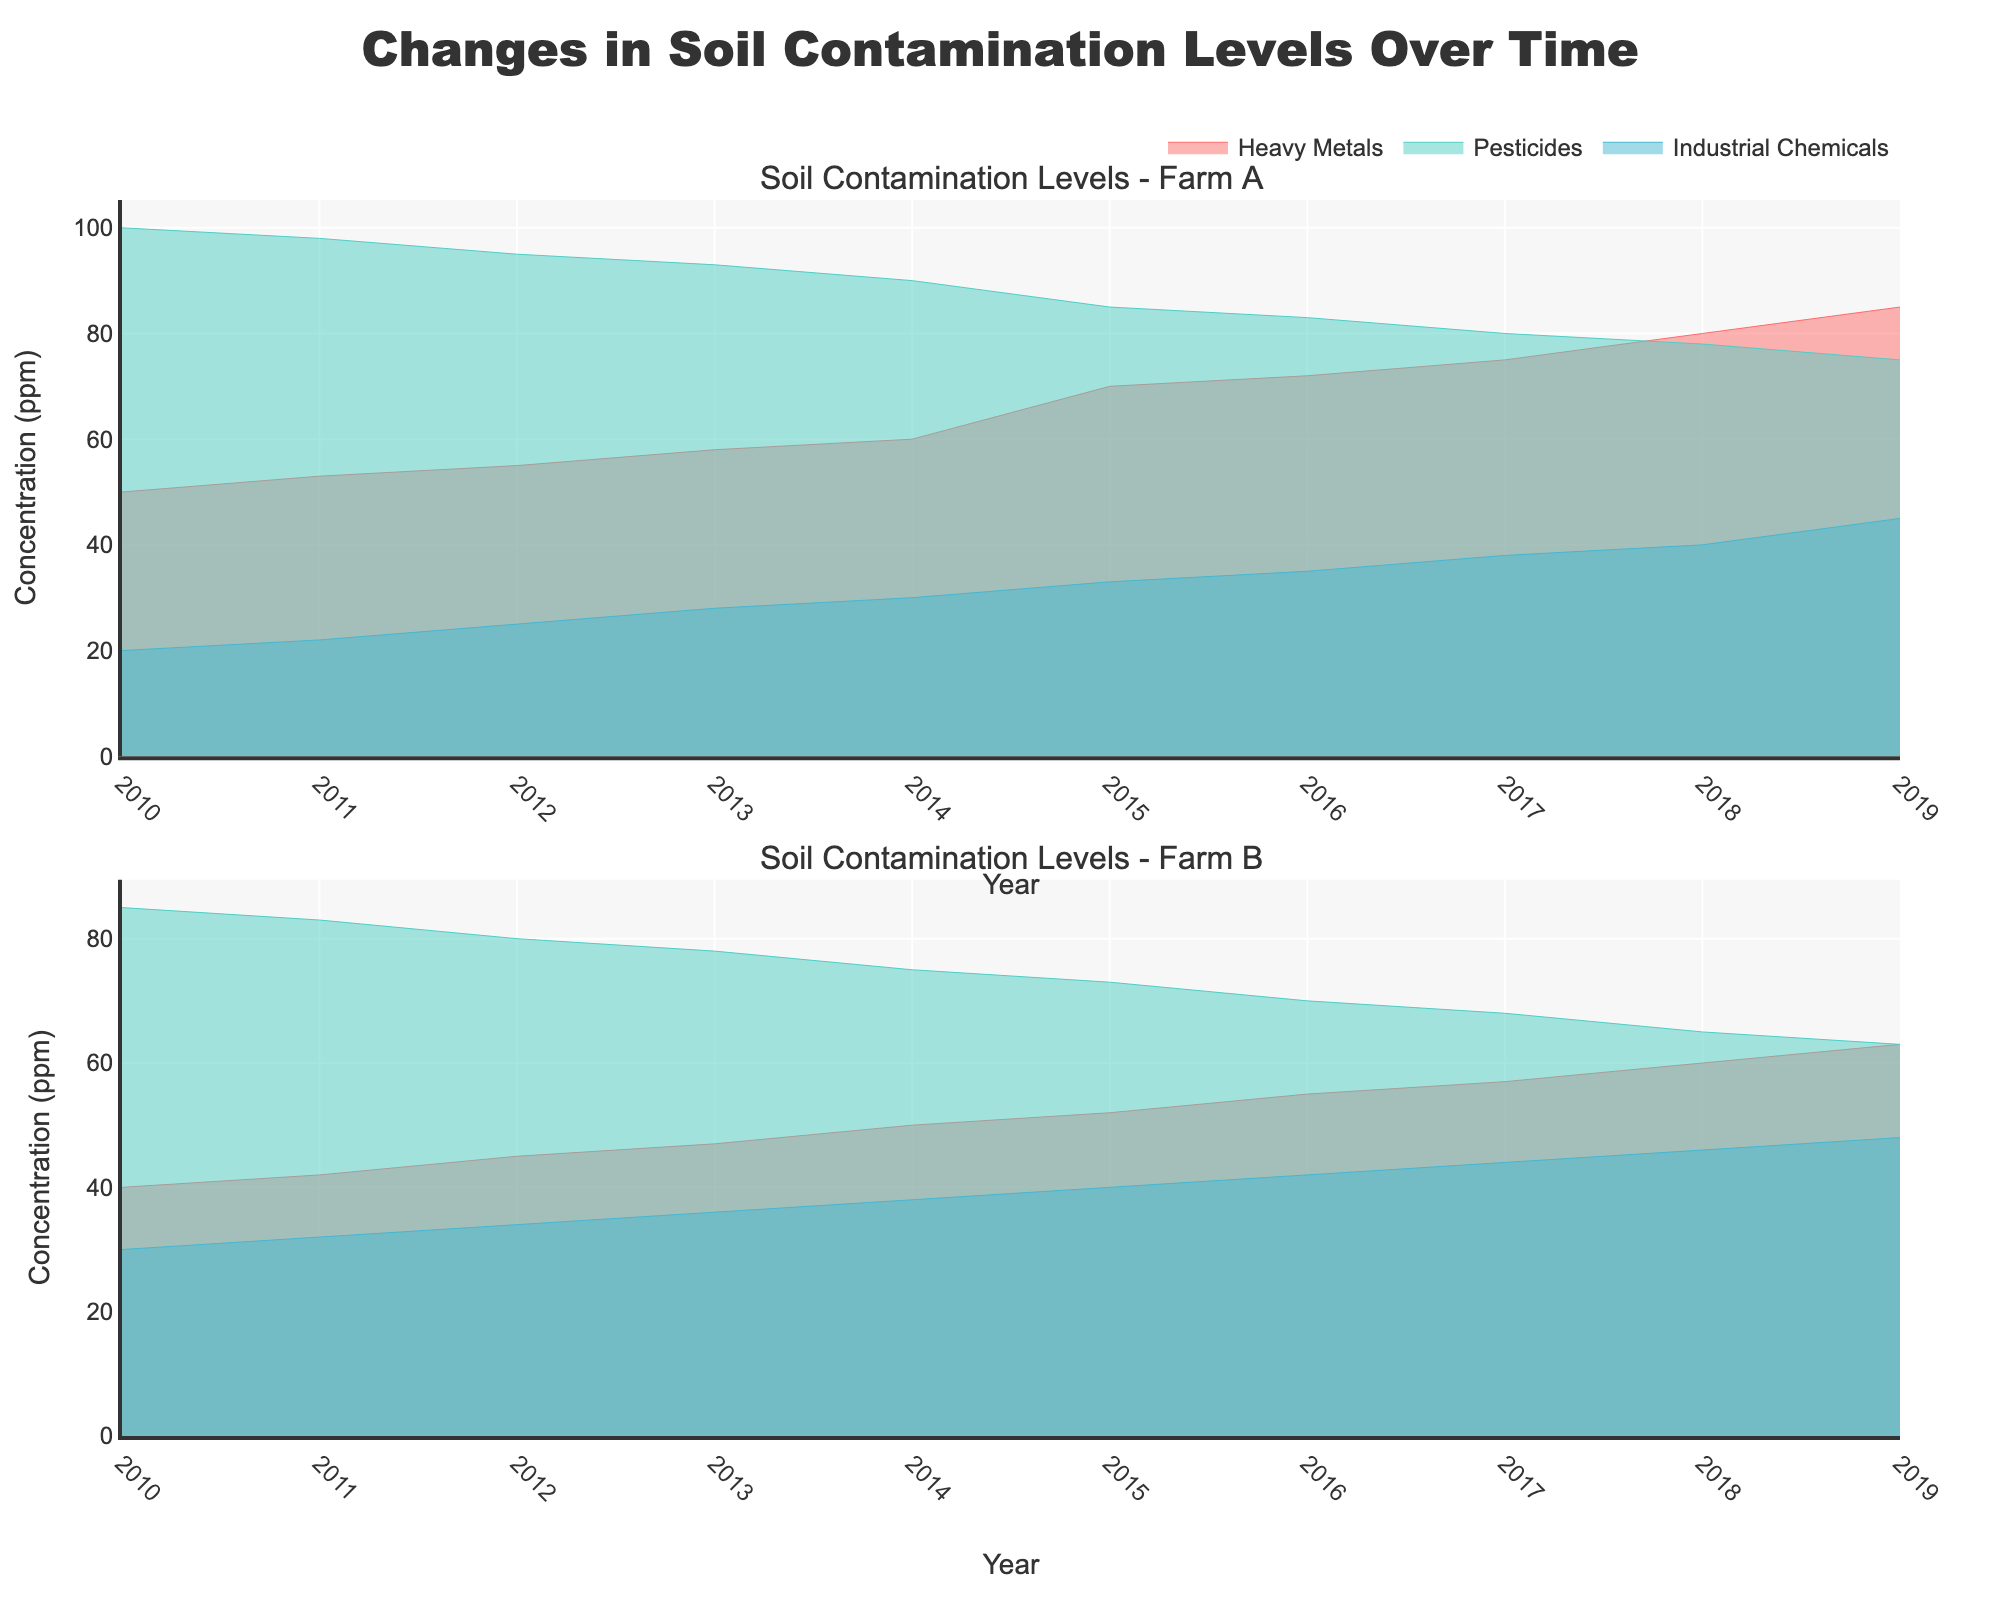What is the title of the plot? The title is located at the top of the plot and is styled in a larger, bold font.
Answer: Changes in Soil Contamination Levels Over Time What is the average concentration of pesticides at Farm A from 2010 to 2019? First, identify the pesticide concentrations at Farm A for each year: 100, 98, 95, 93, 90, 85, 83, 80, 78, 75. Sum these values (877) and divide by the number of years (10).
Answer: 87.7 ppm Which pollutant type shows an increasing trend in concentrations over time at Farm B? Observe the lines for different pollutant types at Farm B and notice their trends. Heavy Metals and Industrial Chemicals both show an increasing trend, while Pesticides show a decreasing trend.
Answer: Heavy Metals, Industrial Chemicals What is the pollutant type with the highest concentration in 2019 at Farm A? Look at the data points at the year 2019 for each pollutant type at Farm A. Heavy Metals have a concentration of 85 ppm, Pesticides have 75 ppm, and Industrial Chemicals have 45 ppm.
Answer: Heavy Metals How does the concentration of Heavy Metals in 2010 at Farm A compare to that in 2019? Compare the concentration of Heavy Metals for the year 2010 (50 ppm) and 2019 (85 ppm) at Farm A. The concentration increased by 35 ppm.
Answer: Increased by 35 ppm What pollutant type decreased the most over time at Farm A? Observe the start and end points for each pollutant type at Farm A. Pesticides show the highest decrease, from 100 ppm in 2010 to 75 ppm in 2019.
Answer: Pesticides Which year saw the highest concentration of Industrial Chemicals at Farm B? Look at the Industrial Chemicals concentration line at Farm B and identify the highest point in the timeframe provided.
Answer: 2019 Compare the trend of Pesticides at Farm A and Farm B. Which farm shows a steeper decline? Compare the slope of the Pesticides concentration lines from 2010 to 2019 for both farms. Farm A's concentration falls from 100 to 75 ppm (25 ppm decline), while Farm B's concentration falls from 85 to 63 ppm (22 ppm decline).
Answer: Farm A Which farm had higher concentrations of Heavy Metals in 2015? Compare the concentration values of Heavy Metals for both farms in the year 2015. Farm A has 70 ppm, and Farm B has 52 ppm of Heavy Metals in 2015.
Answer: Farm A 